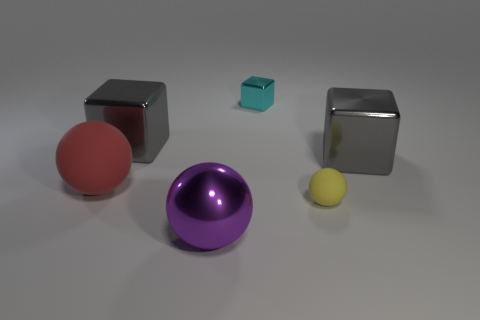What is the tiny ball made of?
Offer a very short reply. Rubber. What number of other things are made of the same material as the red ball?
Ensure brevity in your answer.  1. There is a sphere that is both behind the large metallic sphere and in front of the red thing; what is its size?
Your response must be concise. Small. There is a tiny matte thing that is left of the gray metallic block on the right side of the cyan shiny cube; what is its shape?
Provide a succinct answer. Sphere. Is there any other thing that is the same shape as the small rubber thing?
Offer a terse response. Yes. Are there an equal number of large rubber things that are in front of the big red thing and big metallic things?
Give a very brief answer. No. There is a big shiny ball; is it the same color as the big block that is on the right side of the cyan block?
Ensure brevity in your answer.  No. What is the color of the ball that is both behind the purple metal ball and to the left of the yellow thing?
Offer a very short reply. Red. There is a large sphere that is in front of the large red rubber sphere; what number of large red matte spheres are in front of it?
Offer a terse response. 0. Is there a large red rubber object of the same shape as the purple metallic thing?
Keep it short and to the point. Yes. 